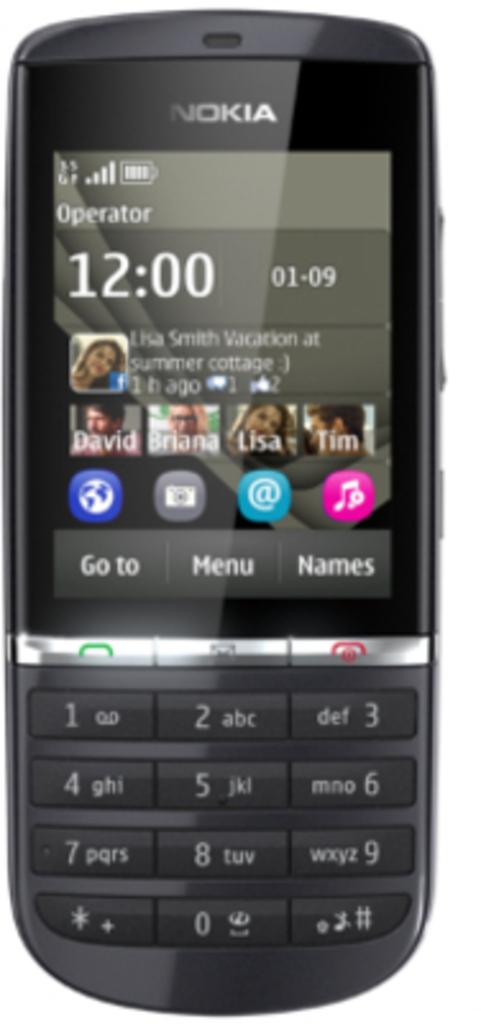Where is the menu button?
Provide a short and direct response. Middle. What time does the smartphone say it is?
Your response must be concise. 12:00. 